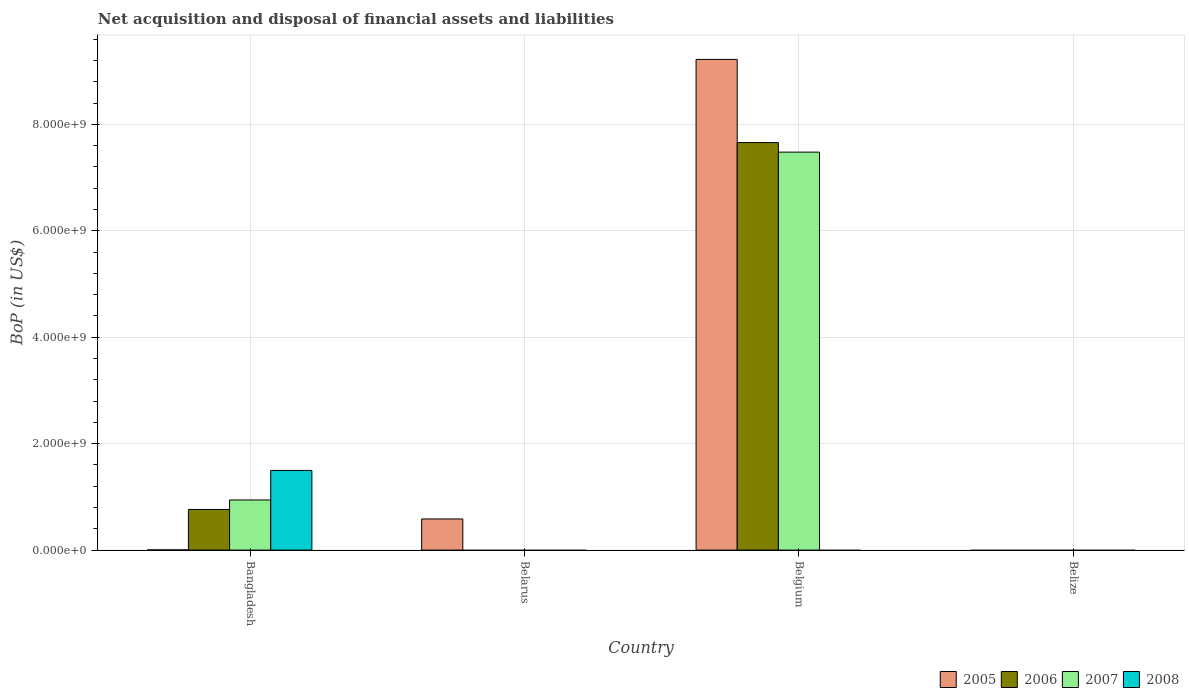Are the number of bars per tick equal to the number of legend labels?
Your answer should be compact. No. Are the number of bars on each tick of the X-axis equal?
Offer a terse response. No. How many bars are there on the 4th tick from the left?
Provide a short and direct response. 0. How many bars are there on the 3rd tick from the right?
Provide a succinct answer. 1. What is the label of the 3rd group of bars from the left?
Give a very brief answer. Belgium. In how many cases, is the number of bars for a given country not equal to the number of legend labels?
Keep it short and to the point. 3. What is the Balance of Payments in 2005 in Belgium?
Give a very brief answer. 9.22e+09. Across all countries, what is the maximum Balance of Payments in 2006?
Your answer should be very brief. 7.66e+09. What is the total Balance of Payments in 2006 in the graph?
Offer a terse response. 8.42e+09. What is the difference between the Balance of Payments in 2005 in Bangladesh and that in Belarus?
Offer a terse response. -5.82e+08. What is the difference between the Balance of Payments in 2008 in Belarus and the Balance of Payments in 2005 in Bangladesh?
Your answer should be compact. -3.42e+06. What is the average Balance of Payments in 2006 per country?
Provide a succinct answer. 2.11e+09. What is the difference between the Balance of Payments of/in 2005 and Balance of Payments of/in 2007 in Bangladesh?
Your answer should be compact. -9.39e+08. Is the Balance of Payments in 2007 in Bangladesh less than that in Belgium?
Ensure brevity in your answer.  Yes. Is the difference between the Balance of Payments in 2005 in Bangladesh and Belgium greater than the difference between the Balance of Payments in 2007 in Bangladesh and Belgium?
Ensure brevity in your answer.  No. What is the difference between the highest and the second highest Balance of Payments in 2005?
Keep it short and to the point. 5.82e+08. What is the difference between the highest and the lowest Balance of Payments in 2008?
Provide a succinct answer. 1.50e+09. Is the sum of the Balance of Payments in 2005 in Bangladesh and Belgium greater than the maximum Balance of Payments in 2006 across all countries?
Provide a succinct answer. Yes. Is it the case that in every country, the sum of the Balance of Payments in 2008 and Balance of Payments in 2005 is greater than the sum of Balance of Payments in 2006 and Balance of Payments in 2007?
Offer a very short reply. No. How many bars are there?
Ensure brevity in your answer.  8. What is the difference between two consecutive major ticks on the Y-axis?
Make the answer very short. 2.00e+09. Does the graph contain grids?
Make the answer very short. Yes. Where does the legend appear in the graph?
Provide a succinct answer. Bottom right. How are the legend labels stacked?
Provide a short and direct response. Horizontal. What is the title of the graph?
Your answer should be very brief. Net acquisition and disposal of financial assets and liabilities. What is the label or title of the Y-axis?
Your response must be concise. BoP (in US$). What is the BoP (in US$) of 2005 in Bangladesh?
Ensure brevity in your answer.  3.42e+06. What is the BoP (in US$) of 2006 in Bangladesh?
Your response must be concise. 7.64e+08. What is the BoP (in US$) in 2007 in Bangladesh?
Make the answer very short. 9.42e+08. What is the BoP (in US$) in 2008 in Bangladesh?
Provide a short and direct response. 1.50e+09. What is the BoP (in US$) of 2005 in Belarus?
Your answer should be compact. 5.85e+08. What is the BoP (in US$) of 2008 in Belarus?
Provide a short and direct response. 0. What is the BoP (in US$) in 2005 in Belgium?
Offer a terse response. 9.22e+09. What is the BoP (in US$) of 2006 in Belgium?
Your answer should be compact. 7.66e+09. What is the BoP (in US$) in 2007 in Belgium?
Keep it short and to the point. 7.48e+09. What is the BoP (in US$) in 2008 in Belgium?
Provide a succinct answer. 0. What is the BoP (in US$) in 2005 in Belize?
Keep it short and to the point. 0. Across all countries, what is the maximum BoP (in US$) in 2005?
Ensure brevity in your answer.  9.22e+09. Across all countries, what is the maximum BoP (in US$) of 2006?
Make the answer very short. 7.66e+09. Across all countries, what is the maximum BoP (in US$) of 2007?
Provide a short and direct response. 7.48e+09. Across all countries, what is the maximum BoP (in US$) of 2008?
Offer a very short reply. 1.50e+09. Across all countries, what is the minimum BoP (in US$) of 2006?
Provide a short and direct response. 0. Across all countries, what is the minimum BoP (in US$) of 2008?
Your answer should be compact. 0. What is the total BoP (in US$) of 2005 in the graph?
Give a very brief answer. 9.81e+09. What is the total BoP (in US$) of 2006 in the graph?
Offer a very short reply. 8.42e+09. What is the total BoP (in US$) of 2007 in the graph?
Your answer should be compact. 8.42e+09. What is the total BoP (in US$) in 2008 in the graph?
Keep it short and to the point. 1.50e+09. What is the difference between the BoP (in US$) in 2005 in Bangladesh and that in Belarus?
Provide a succinct answer. -5.82e+08. What is the difference between the BoP (in US$) in 2005 in Bangladesh and that in Belgium?
Offer a very short reply. -9.22e+09. What is the difference between the BoP (in US$) of 2006 in Bangladesh and that in Belgium?
Ensure brevity in your answer.  -6.89e+09. What is the difference between the BoP (in US$) of 2007 in Bangladesh and that in Belgium?
Offer a very short reply. -6.54e+09. What is the difference between the BoP (in US$) of 2005 in Belarus and that in Belgium?
Provide a short and direct response. -8.63e+09. What is the difference between the BoP (in US$) in 2005 in Bangladesh and the BoP (in US$) in 2006 in Belgium?
Your response must be concise. -7.65e+09. What is the difference between the BoP (in US$) in 2005 in Bangladesh and the BoP (in US$) in 2007 in Belgium?
Ensure brevity in your answer.  -7.47e+09. What is the difference between the BoP (in US$) of 2006 in Bangladesh and the BoP (in US$) of 2007 in Belgium?
Your answer should be compact. -6.71e+09. What is the difference between the BoP (in US$) of 2005 in Belarus and the BoP (in US$) of 2006 in Belgium?
Your answer should be compact. -7.07e+09. What is the difference between the BoP (in US$) of 2005 in Belarus and the BoP (in US$) of 2007 in Belgium?
Your answer should be compact. -6.89e+09. What is the average BoP (in US$) of 2005 per country?
Your answer should be very brief. 2.45e+09. What is the average BoP (in US$) in 2006 per country?
Your answer should be compact. 2.11e+09. What is the average BoP (in US$) of 2007 per country?
Provide a short and direct response. 2.10e+09. What is the average BoP (in US$) of 2008 per country?
Your response must be concise. 3.74e+08. What is the difference between the BoP (in US$) in 2005 and BoP (in US$) in 2006 in Bangladesh?
Your answer should be compact. -7.60e+08. What is the difference between the BoP (in US$) of 2005 and BoP (in US$) of 2007 in Bangladesh?
Your answer should be very brief. -9.39e+08. What is the difference between the BoP (in US$) of 2005 and BoP (in US$) of 2008 in Bangladesh?
Your answer should be very brief. -1.49e+09. What is the difference between the BoP (in US$) of 2006 and BoP (in US$) of 2007 in Bangladesh?
Your response must be concise. -1.78e+08. What is the difference between the BoP (in US$) of 2006 and BoP (in US$) of 2008 in Bangladesh?
Provide a short and direct response. -7.33e+08. What is the difference between the BoP (in US$) of 2007 and BoP (in US$) of 2008 in Bangladesh?
Your answer should be compact. -5.55e+08. What is the difference between the BoP (in US$) of 2005 and BoP (in US$) of 2006 in Belgium?
Keep it short and to the point. 1.56e+09. What is the difference between the BoP (in US$) in 2005 and BoP (in US$) in 2007 in Belgium?
Provide a short and direct response. 1.74e+09. What is the difference between the BoP (in US$) in 2006 and BoP (in US$) in 2007 in Belgium?
Offer a very short reply. 1.79e+08. What is the ratio of the BoP (in US$) of 2005 in Bangladesh to that in Belarus?
Make the answer very short. 0.01. What is the ratio of the BoP (in US$) in 2005 in Bangladesh to that in Belgium?
Keep it short and to the point. 0. What is the ratio of the BoP (in US$) of 2006 in Bangladesh to that in Belgium?
Your answer should be very brief. 0.1. What is the ratio of the BoP (in US$) of 2007 in Bangladesh to that in Belgium?
Keep it short and to the point. 0.13. What is the ratio of the BoP (in US$) in 2005 in Belarus to that in Belgium?
Provide a succinct answer. 0.06. What is the difference between the highest and the second highest BoP (in US$) in 2005?
Your answer should be very brief. 8.63e+09. What is the difference between the highest and the lowest BoP (in US$) in 2005?
Keep it short and to the point. 9.22e+09. What is the difference between the highest and the lowest BoP (in US$) in 2006?
Your answer should be very brief. 7.66e+09. What is the difference between the highest and the lowest BoP (in US$) of 2007?
Ensure brevity in your answer.  7.48e+09. What is the difference between the highest and the lowest BoP (in US$) in 2008?
Your answer should be compact. 1.50e+09. 